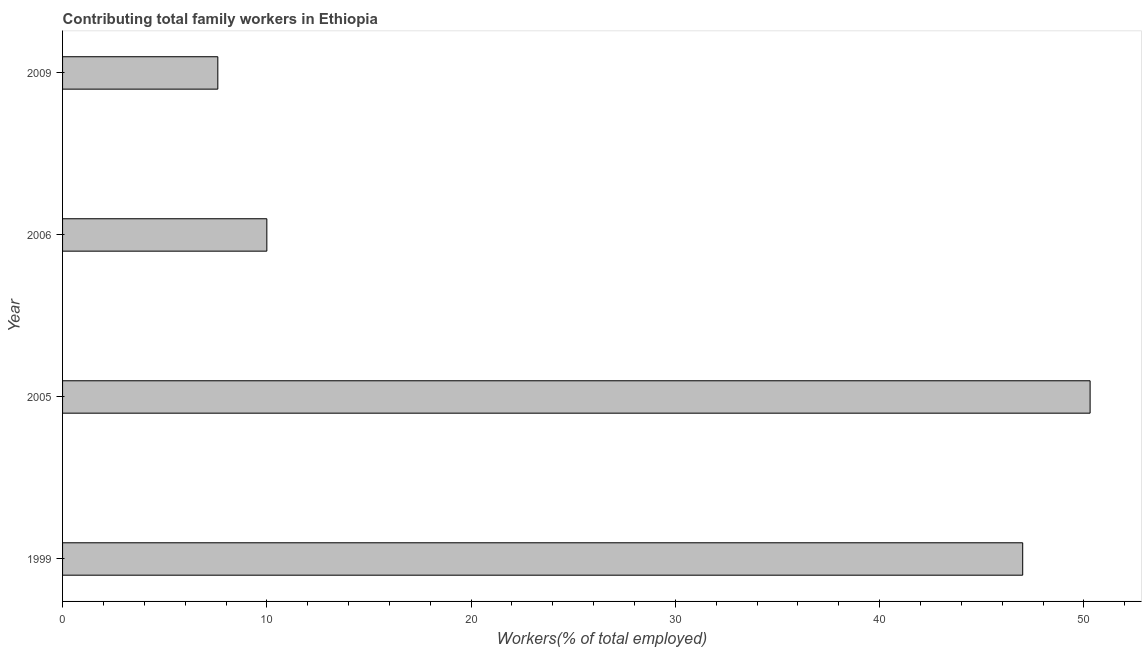What is the title of the graph?
Your response must be concise. Contributing total family workers in Ethiopia. What is the label or title of the X-axis?
Ensure brevity in your answer.  Workers(% of total employed). What is the label or title of the Y-axis?
Ensure brevity in your answer.  Year. What is the contributing family workers in 2009?
Make the answer very short. 7.6. Across all years, what is the maximum contributing family workers?
Give a very brief answer. 50.3. Across all years, what is the minimum contributing family workers?
Your answer should be compact. 7.6. In which year was the contributing family workers maximum?
Make the answer very short. 2005. In which year was the contributing family workers minimum?
Ensure brevity in your answer.  2009. What is the sum of the contributing family workers?
Keep it short and to the point. 114.9. What is the difference between the contributing family workers in 2005 and 2006?
Your answer should be very brief. 40.3. What is the average contributing family workers per year?
Your response must be concise. 28.73. What is the median contributing family workers?
Offer a terse response. 28.5. In how many years, is the contributing family workers greater than 48 %?
Offer a very short reply. 1. What is the ratio of the contributing family workers in 2005 to that in 2009?
Provide a short and direct response. 6.62. Is the difference between the contributing family workers in 2006 and 2009 greater than the difference between any two years?
Make the answer very short. No. What is the difference between the highest and the second highest contributing family workers?
Ensure brevity in your answer.  3.3. What is the difference between the highest and the lowest contributing family workers?
Provide a succinct answer. 42.7. In how many years, is the contributing family workers greater than the average contributing family workers taken over all years?
Provide a short and direct response. 2. How many bars are there?
Ensure brevity in your answer.  4. Are all the bars in the graph horizontal?
Provide a short and direct response. Yes. How many years are there in the graph?
Keep it short and to the point. 4. What is the Workers(% of total employed) of 2005?
Ensure brevity in your answer.  50.3. What is the Workers(% of total employed) in 2006?
Offer a very short reply. 10. What is the Workers(% of total employed) of 2009?
Give a very brief answer. 7.6. What is the difference between the Workers(% of total employed) in 1999 and 2009?
Your response must be concise. 39.4. What is the difference between the Workers(% of total employed) in 2005 and 2006?
Your answer should be compact. 40.3. What is the difference between the Workers(% of total employed) in 2005 and 2009?
Your answer should be very brief. 42.7. What is the ratio of the Workers(% of total employed) in 1999 to that in 2005?
Your response must be concise. 0.93. What is the ratio of the Workers(% of total employed) in 1999 to that in 2006?
Ensure brevity in your answer.  4.7. What is the ratio of the Workers(% of total employed) in 1999 to that in 2009?
Provide a short and direct response. 6.18. What is the ratio of the Workers(% of total employed) in 2005 to that in 2006?
Offer a terse response. 5.03. What is the ratio of the Workers(% of total employed) in 2005 to that in 2009?
Make the answer very short. 6.62. What is the ratio of the Workers(% of total employed) in 2006 to that in 2009?
Your answer should be very brief. 1.32. 